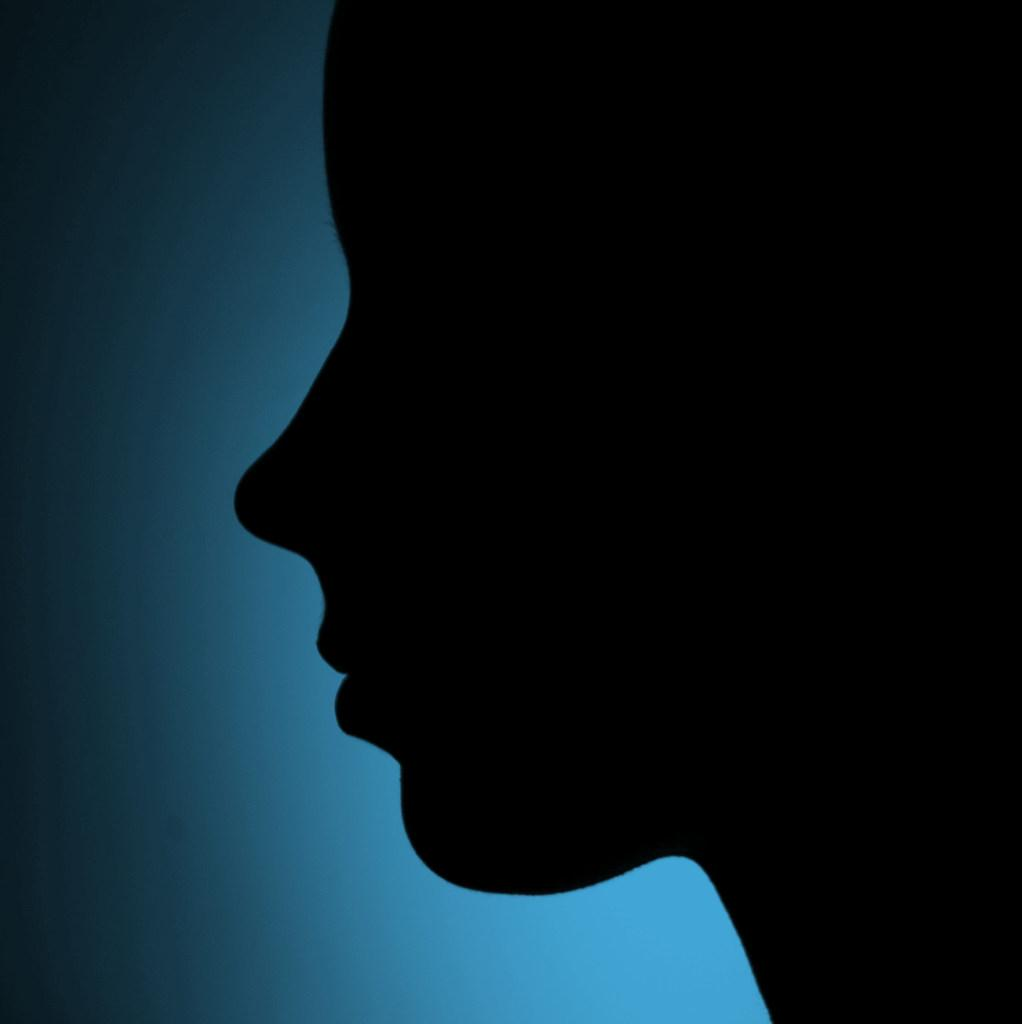What is the main subject of the image? There is a depiction of a face in the image. What color is the face in the image? The face is in black color. What color is the background of the image? The background of the image is blue. How many rings are visible on the nose of the face in the image? There are no rings visible on the nose of the face in the image, as the face is depicted in black color and no additional details are provided. 